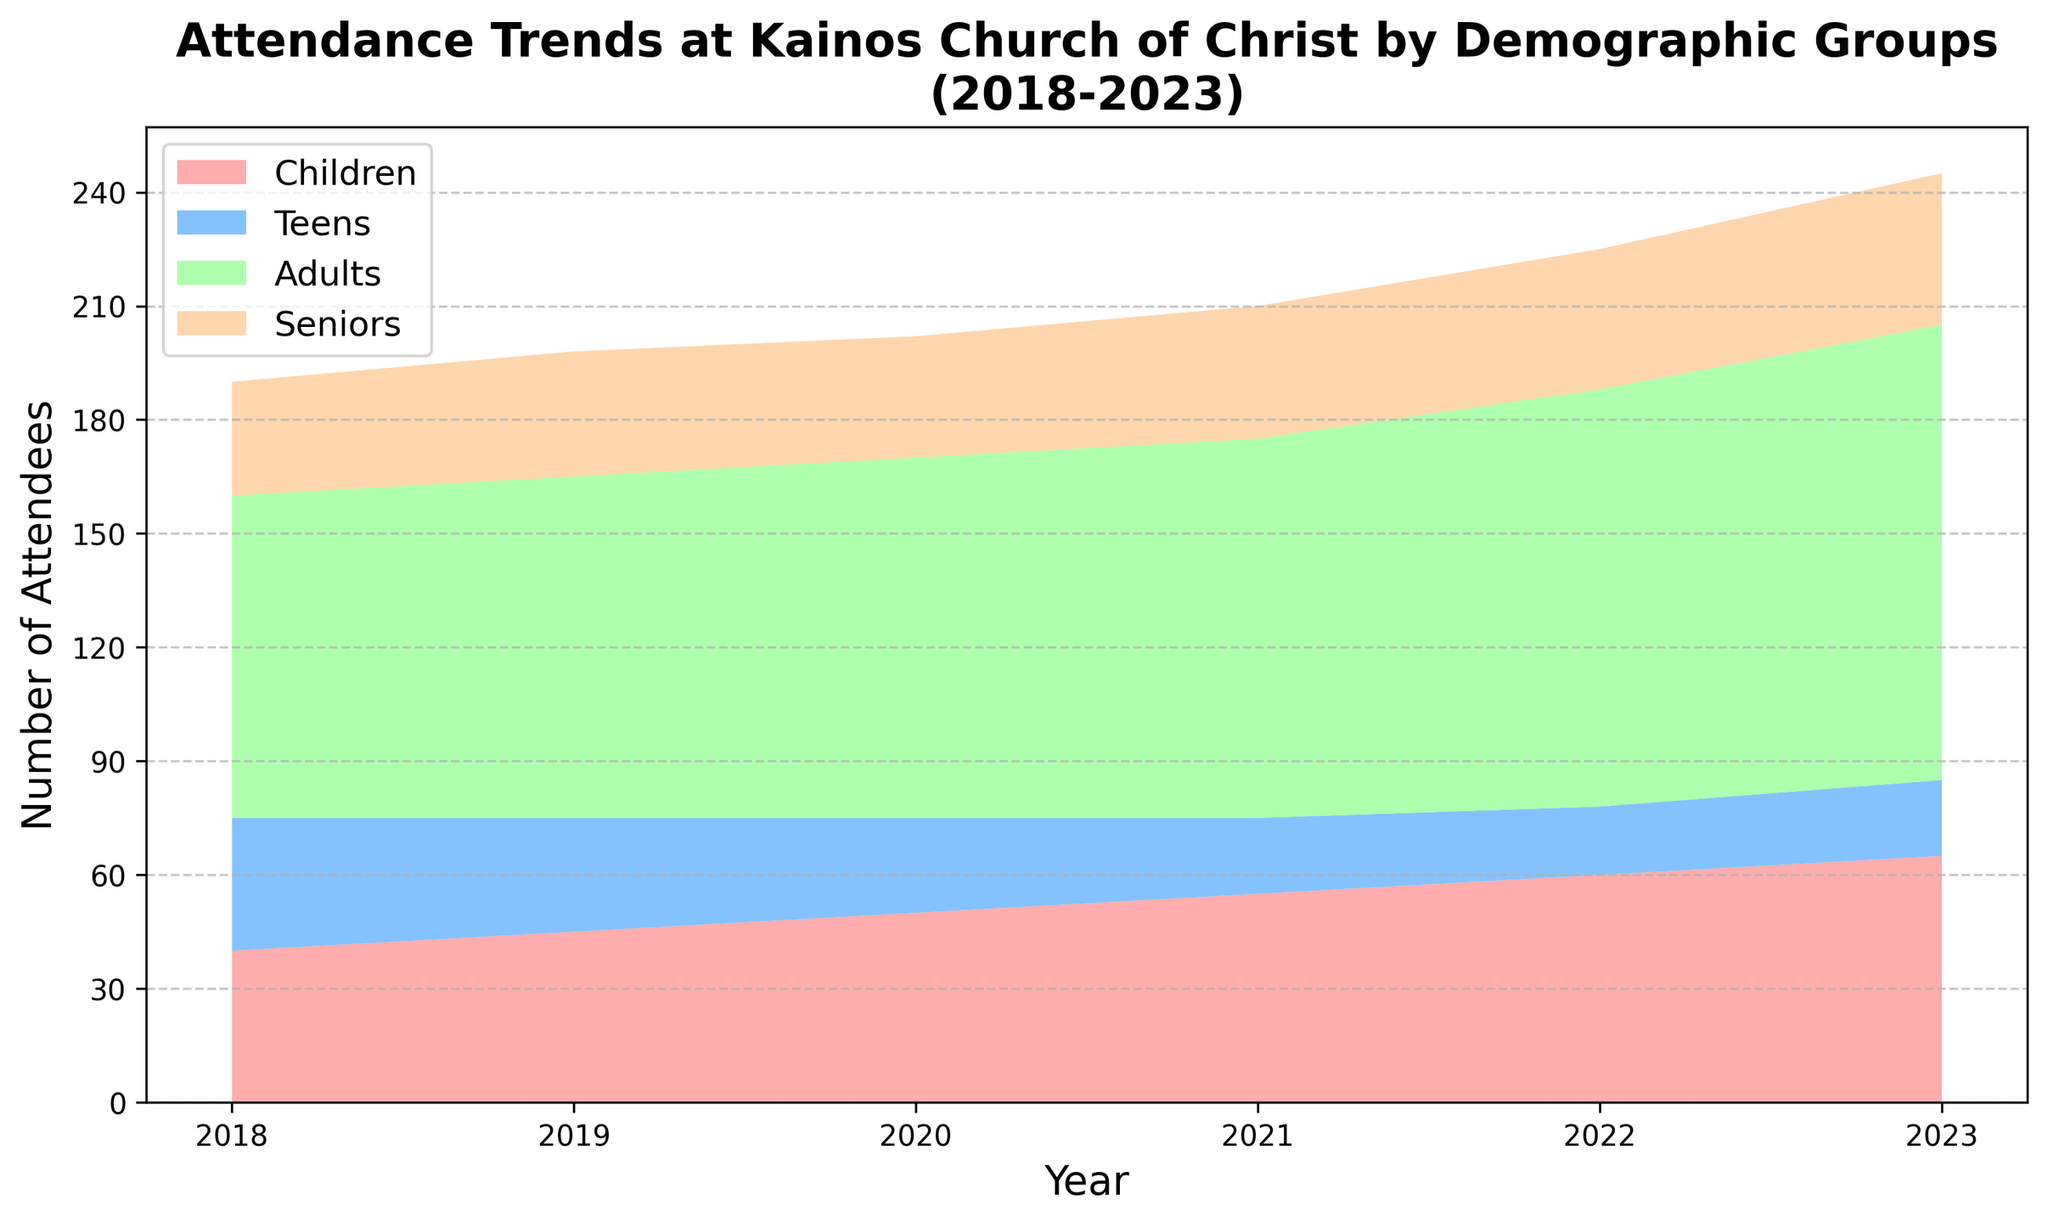What's the trend in attendance for the 'Children' group from 2018 to 2023? The 'Children' group's attendance increases every year from 2018 (40 attendees) to 2023 (65 attendees).
Answer: Increased Which demographic group has the highest attendance in 2023? In 2023, the 'Adults' group has the highest attendance with 120 attendees.
Answer: Adults Between which consecutive years did the 'Teens' group's attendance decrease the most? Comparing the drop in attendance for the 'Teens' group each year, the largest decrease occurs between 2018 (35) and 2019 (30) where it drops by 5 attendees.
Answer: 2018 to 2019 How does the attendance of the 'Seniors' group change from 2018 to 2023? The 'Seniors' group's attendance gradually increases from 30 attendees in 2018 to 40 attendees in 2023.
Answer: Increased In which year did the total attendance of all groups combined reach the highest level? Summing up all attendees for each year, the highest total attendance is in 2023 with (65 + 20 + 120 + 40) = 245 attendees.
Answer: 2023 Which demographic shows the most stable attendance trend over the five-year period? The 'Seniors' group's attendance changes moderately each year (30, 33, 32, 35, 37, 40), showing the least fluctuation compared to other groups.
Answer: Seniors What was the total attendance in 2020? Summing up the number of attendees in 2020 for all groups: (50 + 25 + 95 + 32) = 202 attendees.
Answer: 202 How much did the attendance of the 'Adults' group increase from 2018 to 2023? The attendance of the 'Adults' group increased from 85 in 2018 to 120 in 2023. The increase is (120 - 85) = 35 attendees.
Answer: 35 Which demographic group had a decreasing attendance trend between 2018 and 2022? The 'Teens' group had a decreasing trend from 2018 (35) through 2022 (18).
Answer: Teens Comparing the 'Children' and 'Seniors' groups, which one had a higher absolute increase in attendance from 2018 to 2023? The 'Children' group increased from 40 to 65, an increase of 25 attendees. The 'Seniors' group increased from 30 to 40, an increase of 10 attendees. Therefore, 'Children' had a higher absolute increase.
Answer: Children 